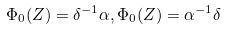<formula> <loc_0><loc_0><loc_500><loc_500>\Phi _ { 0 } ( Z ) = \delta ^ { - 1 } \alpha , \Phi _ { 0 } ( Z ) = \alpha ^ { - 1 } \delta</formula> 